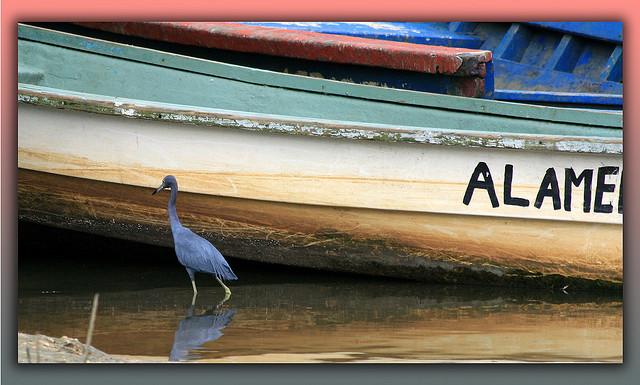What animal is next to the boat?
Write a very short answer. Bird. What color are the letters?
Write a very short answer. Black. What color is the bird?
Concise answer only. Blue. 